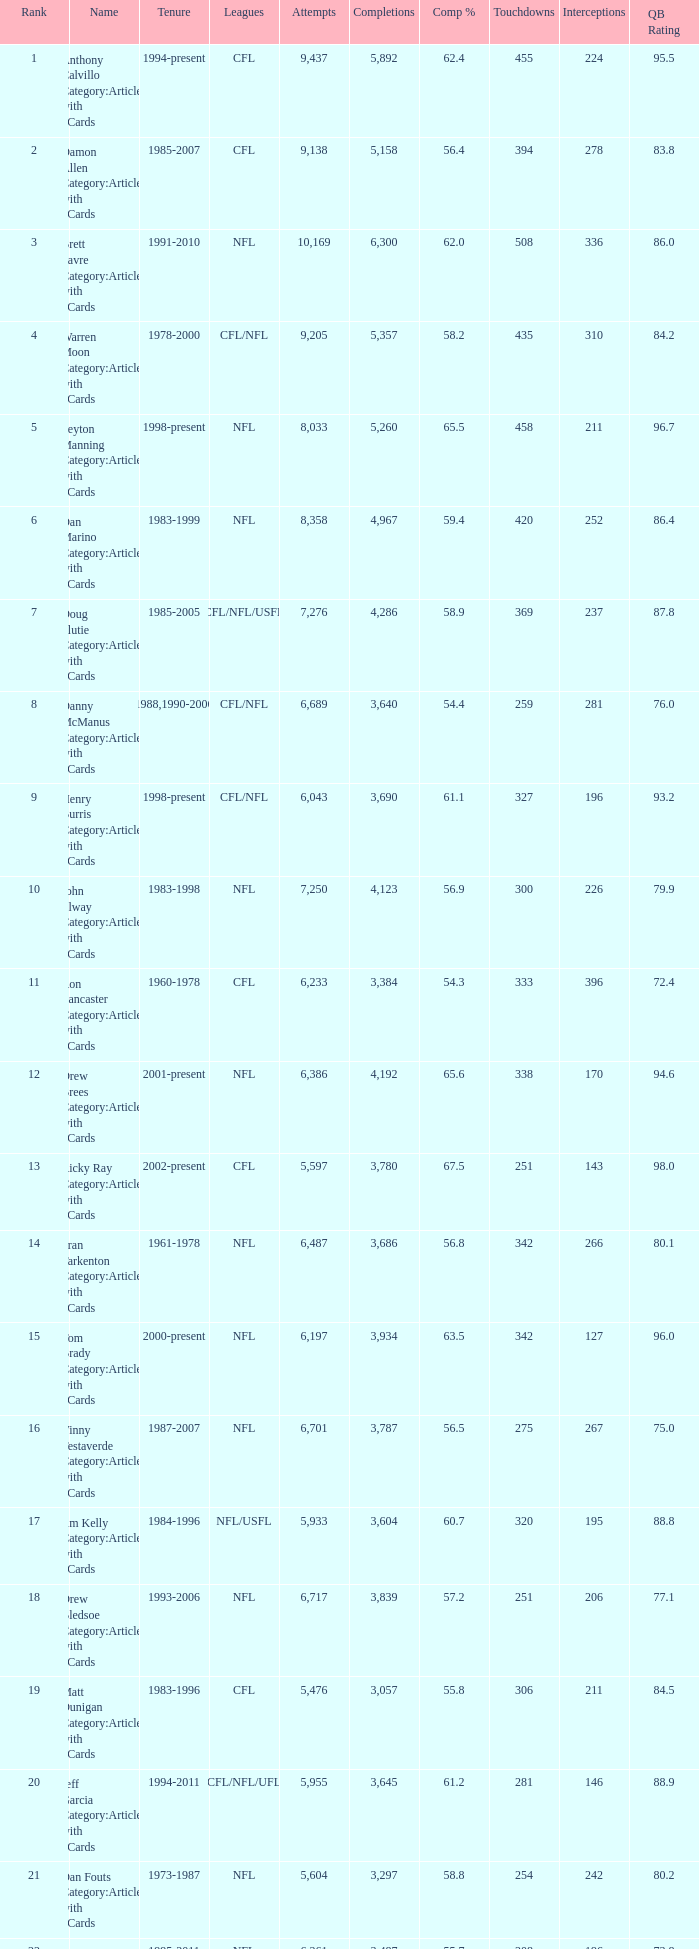What is the comp percentage when there are less than 44,611 in yardage, more than 254 touchdowns, and rank larger than 24? 54.6. Could you parse the entire table? {'header': ['Rank', 'Name', 'Tenure', 'Leagues', 'Attempts', 'Completions', 'Comp %', 'Touchdowns', 'Interceptions', 'QB Rating'], 'rows': [['1', 'Anthony Calvillo Category:Articles with hCards', '1994-present', 'CFL', '9,437', '5,892', '62.4', '455', '224', '95.5'], ['2', 'Damon Allen Category:Articles with hCards', '1985-2007', 'CFL', '9,138', '5,158', '56.4', '394', '278', '83.8'], ['3', 'Brett Favre Category:Articles with hCards', '1991-2010', 'NFL', '10,169', '6,300', '62.0', '508', '336', '86.0'], ['4', 'Warren Moon Category:Articles with hCards', '1978-2000', 'CFL/NFL', '9,205', '5,357', '58.2', '435', '310', '84.2'], ['5', 'Peyton Manning Category:Articles with hCards', '1998-present', 'NFL', '8,033', '5,260', '65.5', '458', '211', '96.7'], ['6', 'Dan Marino Category:Articles with hCards', '1983-1999', 'NFL', '8,358', '4,967', '59.4', '420', '252', '86.4'], ['7', 'Doug Flutie Category:Articles with hCards', '1985-2005', 'CFL/NFL/USFL', '7,276', '4,286', '58.9', '369', '237', '87.8'], ['8', 'Danny McManus Category:Articles with hCards', '1988,1990-2006', 'CFL/NFL', '6,689', '3,640', '54.4', '259', '281', '76.0'], ['9', 'Henry Burris Category:Articles with hCards', '1998-present', 'CFL/NFL', '6,043', '3,690', '61.1', '327', '196', '93.2'], ['10', 'John Elway Category:Articles with hCards', '1983-1998', 'NFL', '7,250', '4,123', '56.9', '300', '226', '79.9'], ['11', 'Ron Lancaster Category:Articles with hCards', '1960-1978', 'CFL', '6,233', '3,384', '54.3', '333', '396', '72.4'], ['12', 'Drew Brees Category:Articles with hCards', '2001-present', 'NFL', '6,386', '4,192', '65.6', '338', '170', '94.6'], ['13', 'Ricky Ray Category:Articles with hCards', '2002-present', 'CFL', '5,597', '3,780', '67.5', '251', '143', '98.0'], ['14', 'Fran Tarkenton Category:Articles with hCards', '1961-1978', 'NFL', '6,487', '3,686', '56.8', '342', '266', '80.1'], ['15', 'Tom Brady Category:Articles with hCards', '2000-present', 'NFL', '6,197', '3,934', '63.5', '342', '127', '96.0'], ['16', 'Vinny Testaverde Category:Articles with hCards', '1987-2007', 'NFL', '6,701', '3,787', '56.5', '275', '267', '75.0'], ['17', 'Jim Kelly Category:Articles with hCards', '1984-1996', 'NFL/USFL', '5,933', '3,604', '60.7', '320', '195', '88.8'], ['18', 'Drew Bledsoe Category:Articles with hCards', '1993-2006', 'NFL', '6,717', '3,839', '57.2', '251', '206', '77.1'], ['19', 'Matt Dunigan Category:Articles with hCards', '1983-1996', 'CFL', '5,476', '3,057', '55.8', '306', '211', '84.5'], ['20', 'Jeff Garcia Category:Articles with hCards', '1994-2011', 'CFL/NFL/UFL', '5,955', '3,645', '61.2', '281', '146', '88.9'], ['21', 'Dan Fouts Category:Articles with hCards', '1973-1987', 'NFL', '5,604', '3,297', '58.8', '254', '242', '80.2'], ['22', 'Kerry Collins Category:Articles with hCards', '1995-2011', 'NFL', '6,261', '3,487', '55.7', '208', '196', '73.8'], ['23', 'Joe Montana Category:Articles with hCards', '1979-1994', 'NFL', '5,391', '3,409', '63.2', '273', '139', '92.3'], ['24', 'Tracy Ham Category:Articles with hCards', '1987-1999', 'CFL', '4,945', '2,670', '54.0', '284', '164', '86.6'], ['25', 'Johnny Unitas Category:Articles with hCards', '1956-1973', 'NFL', '5,186', '2,830', '54.6', '290', '253', '78.2']]} 